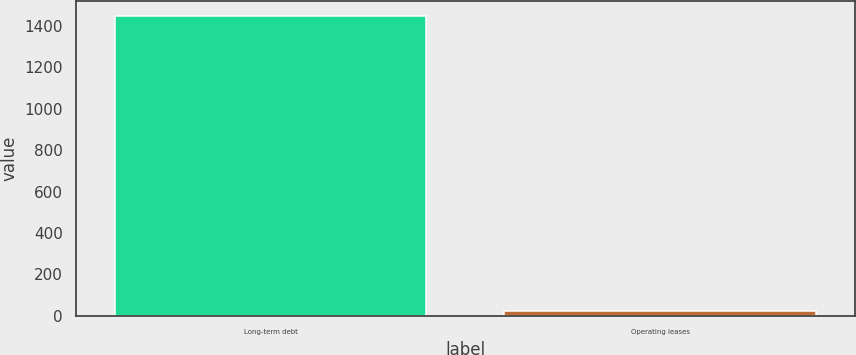Convert chart to OTSL. <chart><loc_0><loc_0><loc_500><loc_500><bar_chart><fcel>Long-term debt<fcel>Operating leases<nl><fcel>1445<fcel>24<nl></chart> 